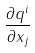<formula> <loc_0><loc_0><loc_500><loc_500>\frac { \partial q ^ { i } } { \partial x _ { j } }</formula> 